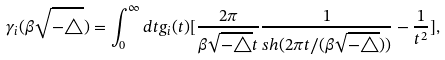Convert formula to latex. <formula><loc_0><loc_0><loc_500><loc_500>\gamma _ { i } ( \beta \sqrt { - \triangle } ) = \int _ { 0 } ^ { \infty } d t g _ { i } ( t ) [ \frac { 2 \pi } { \beta \sqrt { - \triangle } t } \frac { 1 } { s h ( 2 \pi t / ( \beta \sqrt { - \triangle } ) ) } - \frac { 1 } { t ^ { 2 } } ] ,</formula> 